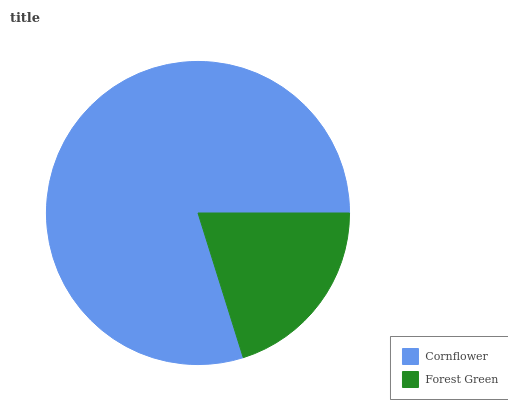Is Forest Green the minimum?
Answer yes or no. Yes. Is Cornflower the maximum?
Answer yes or no. Yes. Is Forest Green the maximum?
Answer yes or no. No. Is Cornflower greater than Forest Green?
Answer yes or no. Yes. Is Forest Green less than Cornflower?
Answer yes or no. Yes. Is Forest Green greater than Cornflower?
Answer yes or no. No. Is Cornflower less than Forest Green?
Answer yes or no. No. Is Cornflower the high median?
Answer yes or no. Yes. Is Forest Green the low median?
Answer yes or no. Yes. Is Forest Green the high median?
Answer yes or no. No. Is Cornflower the low median?
Answer yes or no. No. 